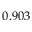Convert formula to latex. <formula><loc_0><loc_0><loc_500><loc_500>0 . 9 0 3</formula> 